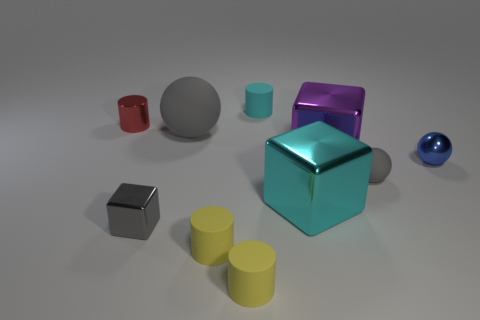Do the large rubber object and the small rubber sphere have the same color?
Offer a terse response. Yes. Is the number of tiny metal objects left of the large gray thing greater than the number of small red cylinders that are behind the tiny red metallic cylinder?
Give a very brief answer. Yes. Do the ball that is on the left side of the tiny gray matte ball and the gray ball to the right of the cyan matte object have the same material?
Provide a succinct answer. Yes. There is a rubber object that is the same size as the purple block; what is its shape?
Provide a succinct answer. Sphere. Are there any other things that have the same shape as the tiny blue shiny object?
Make the answer very short. Yes. There is a rubber cylinder that is behind the small block; is it the same color as the big block that is on the left side of the big purple object?
Ensure brevity in your answer.  Yes. There is a tiny blue shiny ball; are there any spheres in front of it?
Your answer should be very brief. Yes. What is the thing that is on the left side of the big gray matte sphere and on the right side of the tiny red object made of?
Provide a short and direct response. Metal. Are the cube that is left of the large gray ball and the cyan cylinder made of the same material?
Make the answer very short. No. What is the tiny cyan object made of?
Keep it short and to the point. Rubber. 